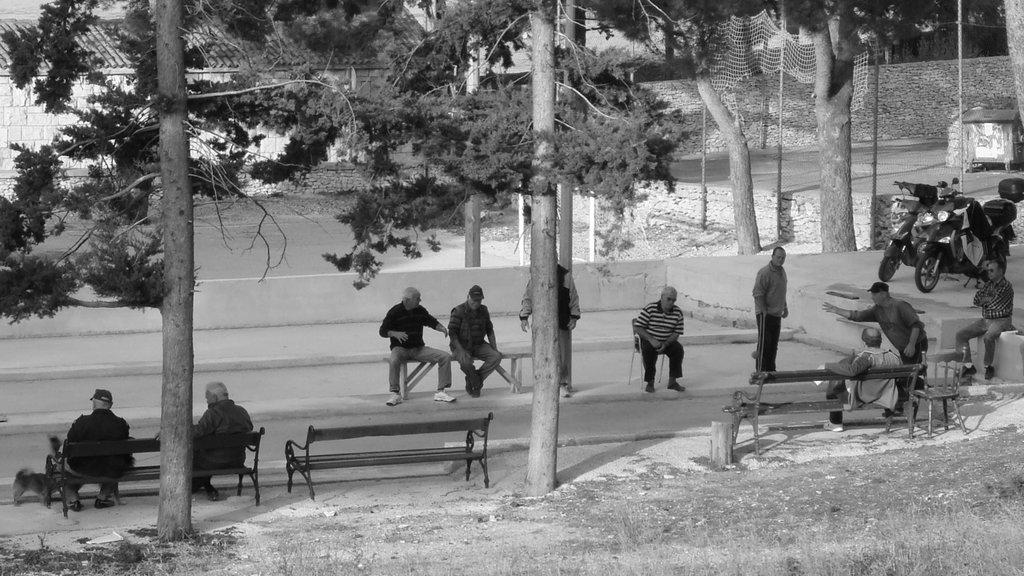What are the people in the image doing? There are persons sitting and standing in the center of the image. What object in the image is not being used? There is an empty bench in the image. What type of natural elements can be seen in the image? There are trees in the image. What man-made objects are present in the image? There are vehicles in the image. What can be seen in the background of the image? There is a wall and a net in the background of the image. What decision is the person on the bench making in the image? There is no person on the bench in the image, and therefore no decision can be observed. What type of knee injury is the person in the image suffering from? There is no mention of a knee injury or any person with an injury in the image. 